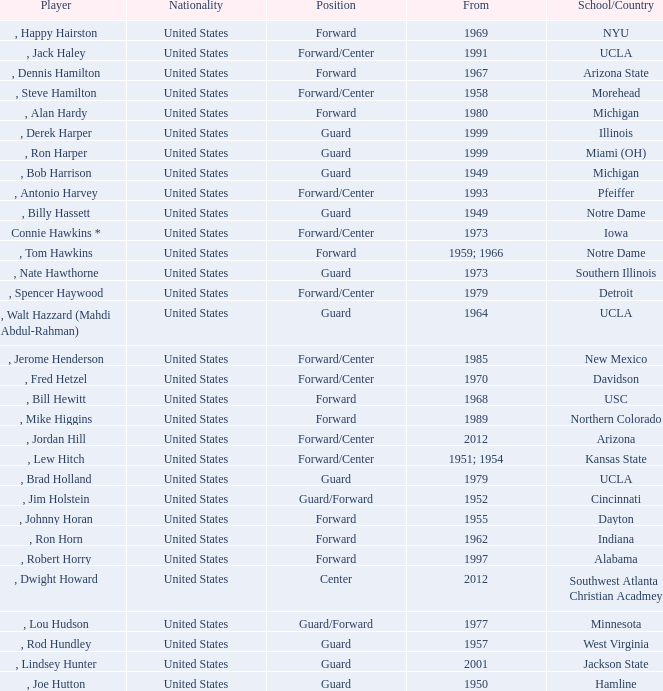Which participant initiated in 2001? , Lindsey Hunter. 